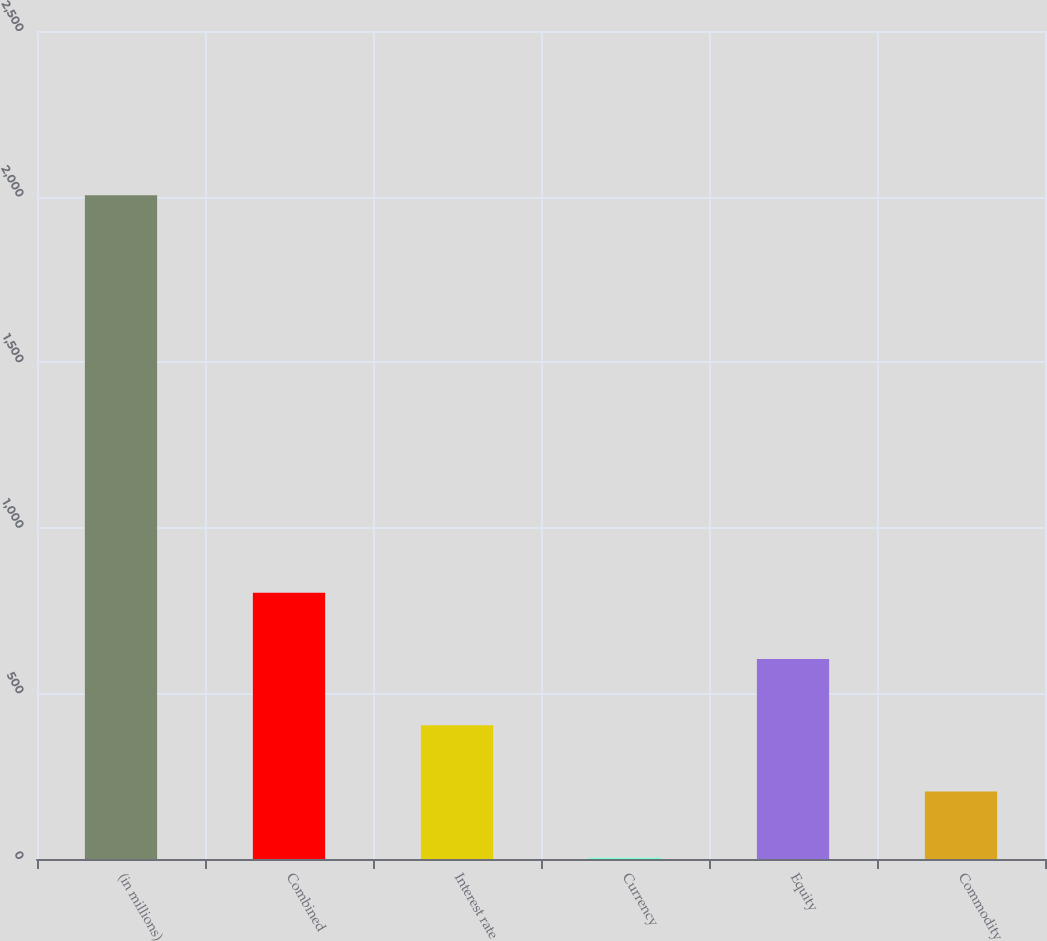Convert chart to OTSL. <chart><loc_0><loc_0><loc_500><loc_500><bar_chart><fcel>(in millions)<fcel>Combined<fcel>Interest rate<fcel>Currency<fcel>Equity<fcel>Commodity<nl><fcel>2004<fcel>804<fcel>404<fcel>4<fcel>604<fcel>204<nl></chart> 